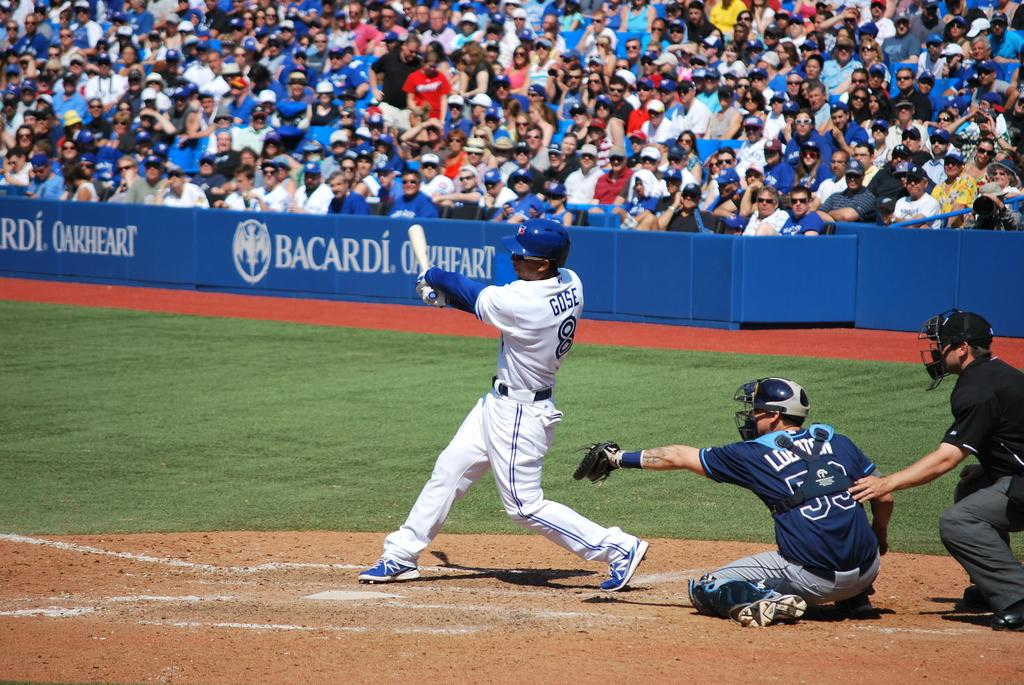<image>
Present a compact description of the photo's key features. A Player is hitting a ball with the last name Gose on his back. 